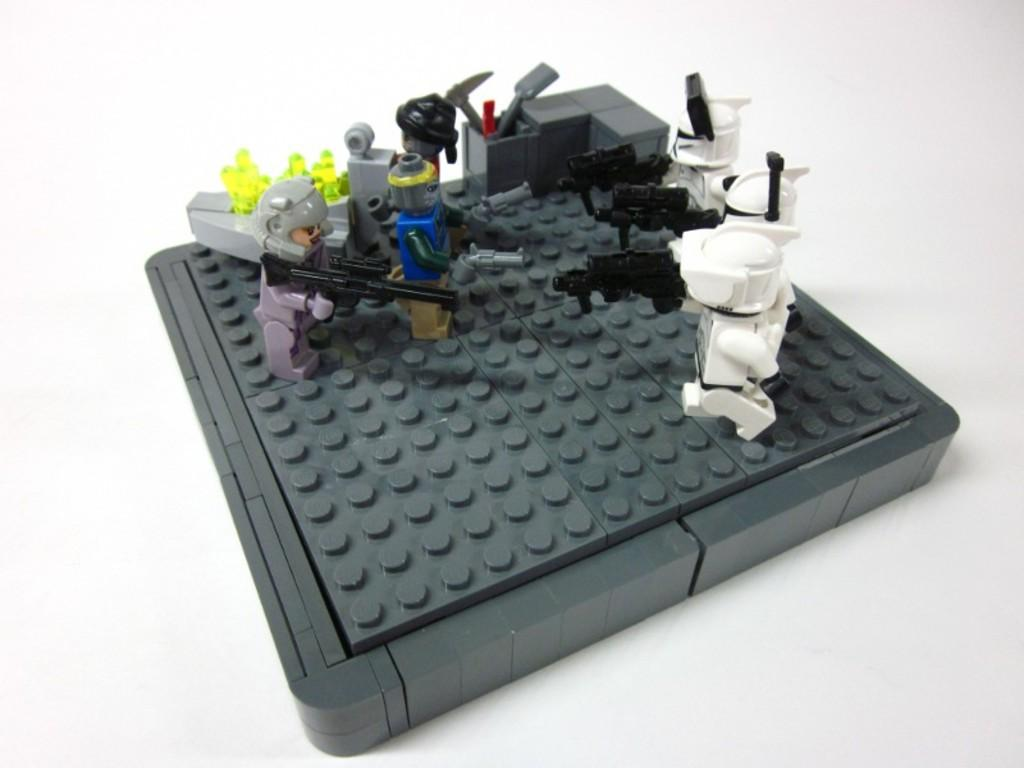What is located in the middle of the picture? There are toys in the middle of the picture. Can you describe the colors of the toys? The toys have various colors, including white, black, blue, green, and grey. What is the color of the background in the image? The background of the image is white. What type of potato is being held by the son in the image? There is no son or potato present in the image; it features toys with various colors. Can you tell me the age of the uncle in the image? There is no uncle present in the image; it features toys with various colors. 